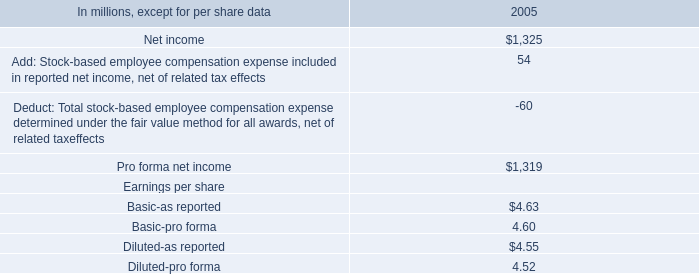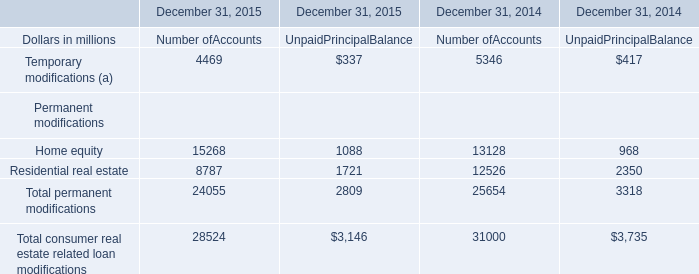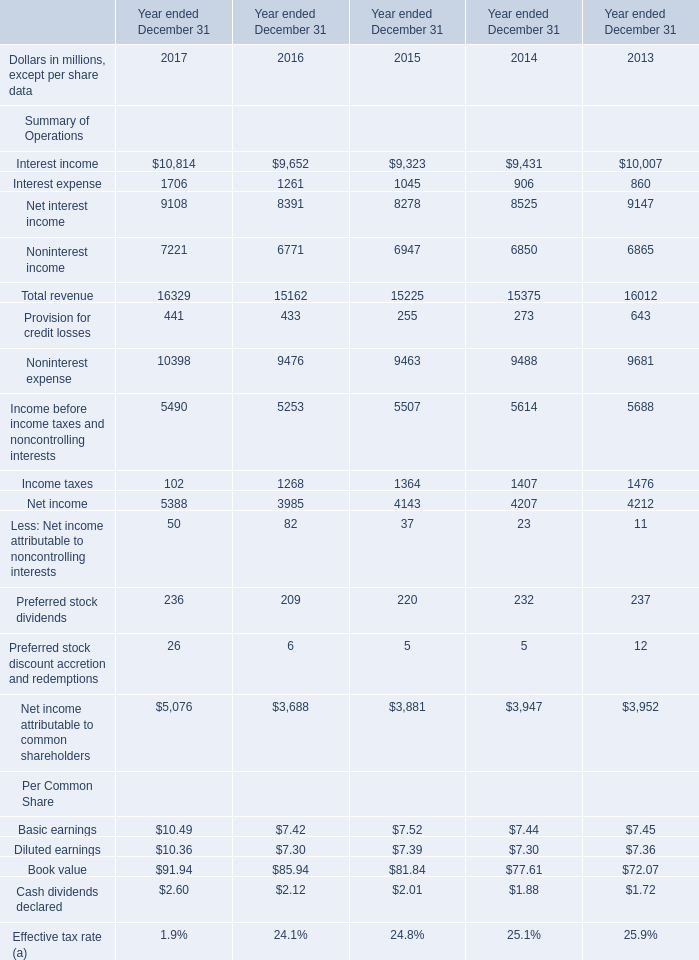What was the average value of Income taxes, Net income, Less: Net income attributable to noncontrolling interests in 2015? (in million) 
Computations: (((1364 + 4143) + 37) / 3)
Answer: 1848.0. 